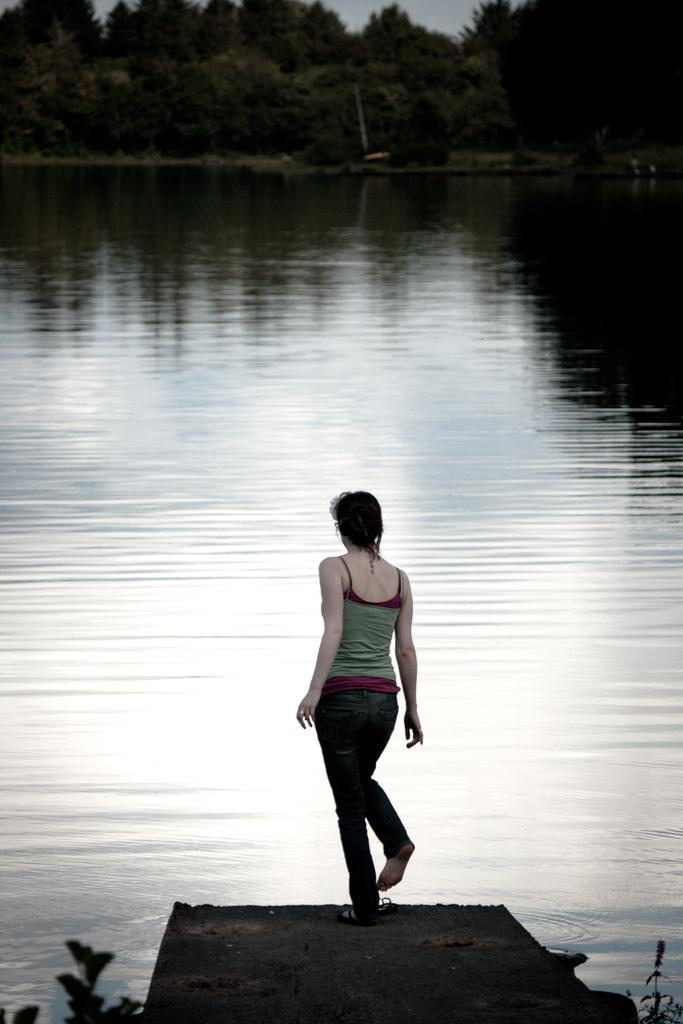What is the main subject of the image? There is a woman in the image. What is the woman doing in the image? The woman is in motion. What type of natural elements can be seen in the image? Leaves and water are visible in the image. What can be seen in the background of the image? There are trees and the sky visible in the background of the image. What type of payment is being made in the image? There is no payment being made in the image; it features a woman in motion with natural elements and a background. Can you tell me how many quivers are visible in the image? There are no quivers present in the image. 